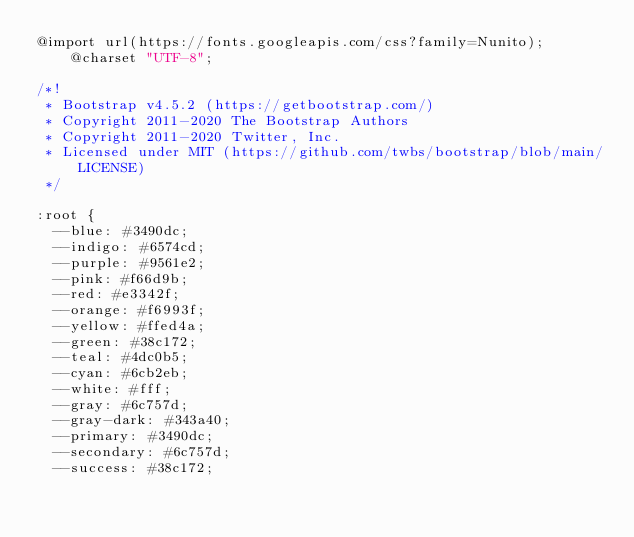Convert code to text. <code><loc_0><loc_0><loc_500><loc_500><_CSS_>@import url(https://fonts.googleapis.com/css?family=Nunito);@charset "UTF-8";

/*!
 * Bootstrap v4.5.2 (https://getbootstrap.com/)
 * Copyright 2011-2020 The Bootstrap Authors
 * Copyright 2011-2020 Twitter, Inc.
 * Licensed under MIT (https://github.com/twbs/bootstrap/blob/main/LICENSE)
 */

:root {
  --blue: #3490dc;
  --indigo: #6574cd;
  --purple: #9561e2;
  --pink: #f66d9b;
  --red: #e3342f;
  --orange: #f6993f;
  --yellow: #ffed4a;
  --green: #38c172;
  --teal: #4dc0b5;
  --cyan: #6cb2eb;
  --white: #fff;
  --gray: #6c757d;
  --gray-dark: #343a40;
  --primary: #3490dc;
  --secondary: #6c757d;
  --success: #38c172;</code> 